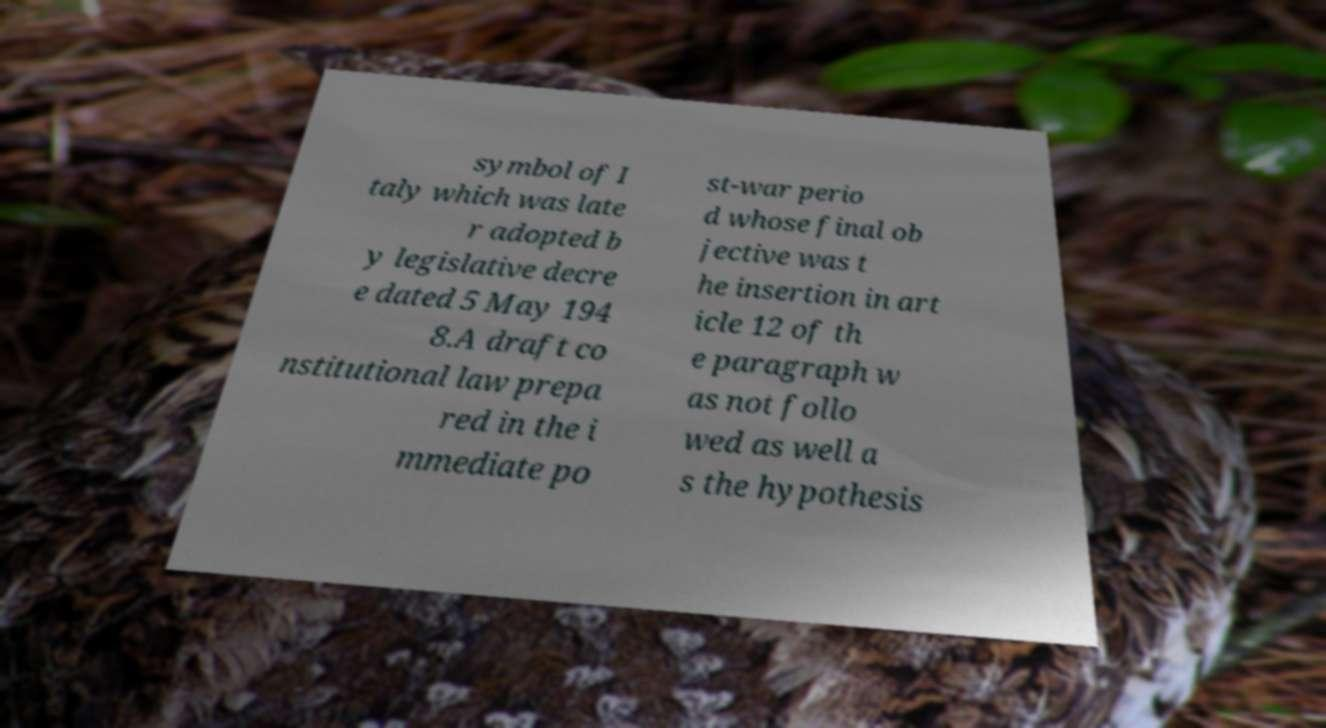Could you extract and type out the text from this image? symbol of I taly which was late r adopted b y legislative decre e dated 5 May 194 8.A draft co nstitutional law prepa red in the i mmediate po st-war perio d whose final ob jective was t he insertion in art icle 12 of th e paragraph w as not follo wed as well a s the hypothesis 